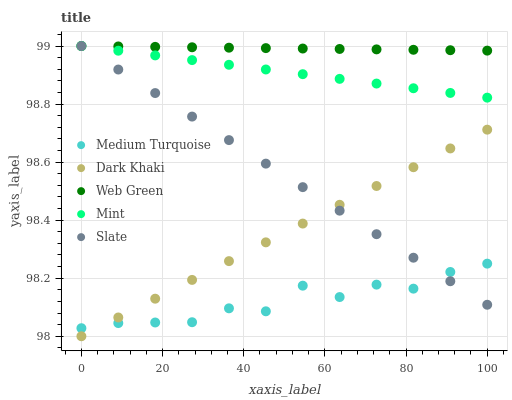Does Medium Turquoise have the minimum area under the curve?
Answer yes or no. Yes. Does Web Green have the maximum area under the curve?
Answer yes or no. Yes. Does Slate have the minimum area under the curve?
Answer yes or no. No. Does Slate have the maximum area under the curve?
Answer yes or no. No. Is Web Green the smoothest?
Answer yes or no. Yes. Is Medium Turquoise the roughest?
Answer yes or no. Yes. Is Slate the smoothest?
Answer yes or no. No. Is Slate the roughest?
Answer yes or no. No. Does Dark Khaki have the lowest value?
Answer yes or no. Yes. Does Slate have the lowest value?
Answer yes or no. No. Does Web Green have the highest value?
Answer yes or no. Yes. Does Medium Turquoise have the highest value?
Answer yes or no. No. Is Dark Khaki less than Mint?
Answer yes or no. Yes. Is Mint greater than Dark Khaki?
Answer yes or no. Yes. Does Mint intersect Slate?
Answer yes or no. Yes. Is Mint less than Slate?
Answer yes or no. No. Is Mint greater than Slate?
Answer yes or no. No. Does Dark Khaki intersect Mint?
Answer yes or no. No. 